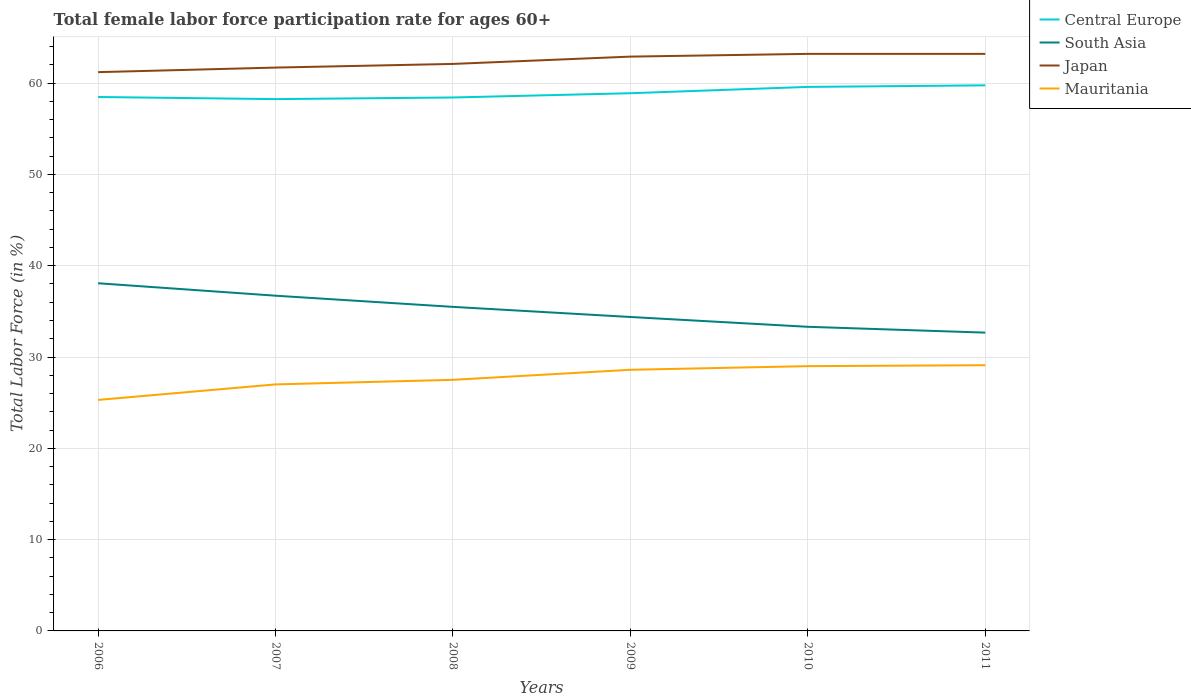How many different coloured lines are there?
Make the answer very short. 4. Is the number of lines equal to the number of legend labels?
Give a very brief answer. Yes. Across all years, what is the maximum female labor force participation rate in Mauritania?
Provide a succinct answer. 25.3. What is the total female labor force participation rate in South Asia in the graph?
Ensure brevity in your answer.  0.64. What is the difference between the highest and the second highest female labor force participation rate in Central Europe?
Provide a succinct answer. 1.51. What is the difference between the highest and the lowest female labor force participation rate in Central Europe?
Provide a short and direct response. 2. How many lines are there?
Keep it short and to the point. 4. How many years are there in the graph?
Make the answer very short. 6. What is the difference between two consecutive major ticks on the Y-axis?
Your answer should be compact. 10. Where does the legend appear in the graph?
Your response must be concise. Top right. What is the title of the graph?
Give a very brief answer. Total female labor force participation rate for ages 60+. Does "Indonesia" appear as one of the legend labels in the graph?
Ensure brevity in your answer.  No. What is the label or title of the Y-axis?
Keep it short and to the point. Total Labor Force (in %). What is the Total Labor Force (in %) of Central Europe in 2006?
Provide a succinct answer. 58.48. What is the Total Labor Force (in %) of South Asia in 2006?
Offer a terse response. 38.08. What is the Total Labor Force (in %) of Japan in 2006?
Make the answer very short. 61.2. What is the Total Labor Force (in %) of Mauritania in 2006?
Your answer should be very brief. 25.3. What is the Total Labor Force (in %) in Central Europe in 2007?
Your response must be concise. 58.25. What is the Total Labor Force (in %) of South Asia in 2007?
Make the answer very short. 36.72. What is the Total Labor Force (in %) in Japan in 2007?
Offer a very short reply. 61.7. What is the Total Labor Force (in %) in Central Europe in 2008?
Offer a terse response. 58.42. What is the Total Labor Force (in %) in South Asia in 2008?
Provide a succinct answer. 35.49. What is the Total Labor Force (in %) of Japan in 2008?
Your answer should be compact. 62.1. What is the Total Labor Force (in %) in Central Europe in 2009?
Offer a very short reply. 58.89. What is the Total Labor Force (in %) of South Asia in 2009?
Provide a short and direct response. 34.38. What is the Total Labor Force (in %) in Japan in 2009?
Provide a short and direct response. 62.9. What is the Total Labor Force (in %) in Mauritania in 2009?
Offer a terse response. 28.6. What is the Total Labor Force (in %) of Central Europe in 2010?
Your answer should be very brief. 59.58. What is the Total Labor Force (in %) in South Asia in 2010?
Your response must be concise. 33.31. What is the Total Labor Force (in %) of Japan in 2010?
Offer a terse response. 63.2. What is the Total Labor Force (in %) in Mauritania in 2010?
Keep it short and to the point. 29. What is the Total Labor Force (in %) in Central Europe in 2011?
Your response must be concise. 59.75. What is the Total Labor Force (in %) in South Asia in 2011?
Keep it short and to the point. 32.67. What is the Total Labor Force (in %) of Japan in 2011?
Ensure brevity in your answer.  63.2. What is the Total Labor Force (in %) in Mauritania in 2011?
Make the answer very short. 29.1. Across all years, what is the maximum Total Labor Force (in %) in Central Europe?
Provide a short and direct response. 59.75. Across all years, what is the maximum Total Labor Force (in %) in South Asia?
Provide a succinct answer. 38.08. Across all years, what is the maximum Total Labor Force (in %) of Japan?
Provide a succinct answer. 63.2. Across all years, what is the maximum Total Labor Force (in %) in Mauritania?
Keep it short and to the point. 29.1. Across all years, what is the minimum Total Labor Force (in %) in Central Europe?
Make the answer very short. 58.25. Across all years, what is the minimum Total Labor Force (in %) of South Asia?
Ensure brevity in your answer.  32.67. Across all years, what is the minimum Total Labor Force (in %) in Japan?
Offer a very short reply. 61.2. Across all years, what is the minimum Total Labor Force (in %) of Mauritania?
Offer a terse response. 25.3. What is the total Total Labor Force (in %) of Central Europe in the graph?
Keep it short and to the point. 353.37. What is the total Total Labor Force (in %) of South Asia in the graph?
Provide a succinct answer. 210.65. What is the total Total Labor Force (in %) in Japan in the graph?
Provide a short and direct response. 374.3. What is the total Total Labor Force (in %) in Mauritania in the graph?
Provide a short and direct response. 166.5. What is the difference between the Total Labor Force (in %) of Central Europe in 2006 and that in 2007?
Provide a succinct answer. 0.23. What is the difference between the Total Labor Force (in %) of South Asia in 2006 and that in 2007?
Offer a very short reply. 1.36. What is the difference between the Total Labor Force (in %) in Japan in 2006 and that in 2007?
Make the answer very short. -0.5. What is the difference between the Total Labor Force (in %) of Central Europe in 2006 and that in 2008?
Keep it short and to the point. 0.05. What is the difference between the Total Labor Force (in %) of South Asia in 2006 and that in 2008?
Offer a very short reply. 2.59. What is the difference between the Total Labor Force (in %) of Central Europe in 2006 and that in 2009?
Provide a short and direct response. -0.41. What is the difference between the Total Labor Force (in %) of South Asia in 2006 and that in 2009?
Keep it short and to the point. 3.69. What is the difference between the Total Labor Force (in %) of Japan in 2006 and that in 2009?
Your answer should be compact. -1.7. What is the difference between the Total Labor Force (in %) in Mauritania in 2006 and that in 2009?
Offer a terse response. -3.3. What is the difference between the Total Labor Force (in %) in Central Europe in 2006 and that in 2010?
Ensure brevity in your answer.  -1.11. What is the difference between the Total Labor Force (in %) of South Asia in 2006 and that in 2010?
Your response must be concise. 4.77. What is the difference between the Total Labor Force (in %) of Mauritania in 2006 and that in 2010?
Provide a succinct answer. -3.7. What is the difference between the Total Labor Force (in %) in Central Europe in 2006 and that in 2011?
Your answer should be compact. -1.28. What is the difference between the Total Labor Force (in %) in South Asia in 2006 and that in 2011?
Provide a short and direct response. 5.41. What is the difference between the Total Labor Force (in %) in Japan in 2006 and that in 2011?
Make the answer very short. -2. What is the difference between the Total Labor Force (in %) of Mauritania in 2006 and that in 2011?
Offer a terse response. -3.8. What is the difference between the Total Labor Force (in %) in Central Europe in 2007 and that in 2008?
Give a very brief answer. -0.18. What is the difference between the Total Labor Force (in %) in South Asia in 2007 and that in 2008?
Ensure brevity in your answer.  1.22. What is the difference between the Total Labor Force (in %) in Central Europe in 2007 and that in 2009?
Ensure brevity in your answer.  -0.64. What is the difference between the Total Labor Force (in %) in South Asia in 2007 and that in 2009?
Offer a terse response. 2.33. What is the difference between the Total Labor Force (in %) in Mauritania in 2007 and that in 2009?
Provide a short and direct response. -1.6. What is the difference between the Total Labor Force (in %) of Central Europe in 2007 and that in 2010?
Keep it short and to the point. -1.34. What is the difference between the Total Labor Force (in %) of South Asia in 2007 and that in 2010?
Your answer should be very brief. 3.41. What is the difference between the Total Labor Force (in %) of Japan in 2007 and that in 2010?
Give a very brief answer. -1.5. What is the difference between the Total Labor Force (in %) of Mauritania in 2007 and that in 2010?
Your response must be concise. -2. What is the difference between the Total Labor Force (in %) in Central Europe in 2007 and that in 2011?
Your response must be concise. -1.51. What is the difference between the Total Labor Force (in %) in South Asia in 2007 and that in 2011?
Your response must be concise. 4.04. What is the difference between the Total Labor Force (in %) of Central Europe in 2008 and that in 2009?
Your answer should be compact. -0.47. What is the difference between the Total Labor Force (in %) in South Asia in 2008 and that in 2009?
Provide a succinct answer. 1.11. What is the difference between the Total Labor Force (in %) in Japan in 2008 and that in 2009?
Ensure brevity in your answer.  -0.8. What is the difference between the Total Labor Force (in %) in Central Europe in 2008 and that in 2010?
Your answer should be very brief. -1.16. What is the difference between the Total Labor Force (in %) in South Asia in 2008 and that in 2010?
Your response must be concise. 2.18. What is the difference between the Total Labor Force (in %) in Central Europe in 2008 and that in 2011?
Your answer should be compact. -1.33. What is the difference between the Total Labor Force (in %) in South Asia in 2008 and that in 2011?
Your answer should be compact. 2.82. What is the difference between the Total Labor Force (in %) in Japan in 2008 and that in 2011?
Offer a terse response. -1.1. What is the difference between the Total Labor Force (in %) in Mauritania in 2008 and that in 2011?
Provide a short and direct response. -1.6. What is the difference between the Total Labor Force (in %) in Central Europe in 2009 and that in 2010?
Keep it short and to the point. -0.69. What is the difference between the Total Labor Force (in %) of South Asia in 2009 and that in 2010?
Offer a very short reply. 1.07. What is the difference between the Total Labor Force (in %) in Central Europe in 2009 and that in 2011?
Give a very brief answer. -0.86. What is the difference between the Total Labor Force (in %) of South Asia in 2009 and that in 2011?
Make the answer very short. 1.71. What is the difference between the Total Labor Force (in %) of Mauritania in 2009 and that in 2011?
Make the answer very short. -0.5. What is the difference between the Total Labor Force (in %) in Central Europe in 2010 and that in 2011?
Offer a terse response. -0.17. What is the difference between the Total Labor Force (in %) of South Asia in 2010 and that in 2011?
Provide a succinct answer. 0.64. What is the difference between the Total Labor Force (in %) in Japan in 2010 and that in 2011?
Give a very brief answer. 0. What is the difference between the Total Labor Force (in %) of Central Europe in 2006 and the Total Labor Force (in %) of South Asia in 2007?
Provide a succinct answer. 21.76. What is the difference between the Total Labor Force (in %) of Central Europe in 2006 and the Total Labor Force (in %) of Japan in 2007?
Offer a very short reply. -3.22. What is the difference between the Total Labor Force (in %) in Central Europe in 2006 and the Total Labor Force (in %) in Mauritania in 2007?
Keep it short and to the point. 31.48. What is the difference between the Total Labor Force (in %) of South Asia in 2006 and the Total Labor Force (in %) of Japan in 2007?
Ensure brevity in your answer.  -23.62. What is the difference between the Total Labor Force (in %) in South Asia in 2006 and the Total Labor Force (in %) in Mauritania in 2007?
Give a very brief answer. 11.08. What is the difference between the Total Labor Force (in %) in Japan in 2006 and the Total Labor Force (in %) in Mauritania in 2007?
Keep it short and to the point. 34.2. What is the difference between the Total Labor Force (in %) in Central Europe in 2006 and the Total Labor Force (in %) in South Asia in 2008?
Provide a short and direct response. 22.99. What is the difference between the Total Labor Force (in %) of Central Europe in 2006 and the Total Labor Force (in %) of Japan in 2008?
Offer a terse response. -3.62. What is the difference between the Total Labor Force (in %) in Central Europe in 2006 and the Total Labor Force (in %) in Mauritania in 2008?
Keep it short and to the point. 30.98. What is the difference between the Total Labor Force (in %) in South Asia in 2006 and the Total Labor Force (in %) in Japan in 2008?
Keep it short and to the point. -24.02. What is the difference between the Total Labor Force (in %) of South Asia in 2006 and the Total Labor Force (in %) of Mauritania in 2008?
Your response must be concise. 10.58. What is the difference between the Total Labor Force (in %) in Japan in 2006 and the Total Labor Force (in %) in Mauritania in 2008?
Your answer should be compact. 33.7. What is the difference between the Total Labor Force (in %) in Central Europe in 2006 and the Total Labor Force (in %) in South Asia in 2009?
Ensure brevity in your answer.  24.09. What is the difference between the Total Labor Force (in %) of Central Europe in 2006 and the Total Labor Force (in %) of Japan in 2009?
Offer a very short reply. -4.42. What is the difference between the Total Labor Force (in %) in Central Europe in 2006 and the Total Labor Force (in %) in Mauritania in 2009?
Provide a succinct answer. 29.88. What is the difference between the Total Labor Force (in %) in South Asia in 2006 and the Total Labor Force (in %) in Japan in 2009?
Your answer should be compact. -24.82. What is the difference between the Total Labor Force (in %) in South Asia in 2006 and the Total Labor Force (in %) in Mauritania in 2009?
Make the answer very short. 9.48. What is the difference between the Total Labor Force (in %) in Japan in 2006 and the Total Labor Force (in %) in Mauritania in 2009?
Make the answer very short. 32.6. What is the difference between the Total Labor Force (in %) of Central Europe in 2006 and the Total Labor Force (in %) of South Asia in 2010?
Offer a terse response. 25.17. What is the difference between the Total Labor Force (in %) in Central Europe in 2006 and the Total Labor Force (in %) in Japan in 2010?
Offer a terse response. -4.72. What is the difference between the Total Labor Force (in %) of Central Europe in 2006 and the Total Labor Force (in %) of Mauritania in 2010?
Ensure brevity in your answer.  29.48. What is the difference between the Total Labor Force (in %) of South Asia in 2006 and the Total Labor Force (in %) of Japan in 2010?
Make the answer very short. -25.12. What is the difference between the Total Labor Force (in %) of South Asia in 2006 and the Total Labor Force (in %) of Mauritania in 2010?
Provide a succinct answer. 9.08. What is the difference between the Total Labor Force (in %) in Japan in 2006 and the Total Labor Force (in %) in Mauritania in 2010?
Your answer should be compact. 32.2. What is the difference between the Total Labor Force (in %) in Central Europe in 2006 and the Total Labor Force (in %) in South Asia in 2011?
Offer a very short reply. 25.81. What is the difference between the Total Labor Force (in %) of Central Europe in 2006 and the Total Labor Force (in %) of Japan in 2011?
Your answer should be compact. -4.72. What is the difference between the Total Labor Force (in %) of Central Europe in 2006 and the Total Labor Force (in %) of Mauritania in 2011?
Keep it short and to the point. 29.38. What is the difference between the Total Labor Force (in %) in South Asia in 2006 and the Total Labor Force (in %) in Japan in 2011?
Your response must be concise. -25.12. What is the difference between the Total Labor Force (in %) in South Asia in 2006 and the Total Labor Force (in %) in Mauritania in 2011?
Make the answer very short. 8.98. What is the difference between the Total Labor Force (in %) of Japan in 2006 and the Total Labor Force (in %) of Mauritania in 2011?
Give a very brief answer. 32.1. What is the difference between the Total Labor Force (in %) of Central Europe in 2007 and the Total Labor Force (in %) of South Asia in 2008?
Make the answer very short. 22.75. What is the difference between the Total Labor Force (in %) of Central Europe in 2007 and the Total Labor Force (in %) of Japan in 2008?
Your answer should be very brief. -3.85. What is the difference between the Total Labor Force (in %) in Central Europe in 2007 and the Total Labor Force (in %) in Mauritania in 2008?
Make the answer very short. 30.75. What is the difference between the Total Labor Force (in %) in South Asia in 2007 and the Total Labor Force (in %) in Japan in 2008?
Provide a succinct answer. -25.38. What is the difference between the Total Labor Force (in %) of South Asia in 2007 and the Total Labor Force (in %) of Mauritania in 2008?
Your answer should be very brief. 9.22. What is the difference between the Total Labor Force (in %) of Japan in 2007 and the Total Labor Force (in %) of Mauritania in 2008?
Your answer should be compact. 34.2. What is the difference between the Total Labor Force (in %) of Central Europe in 2007 and the Total Labor Force (in %) of South Asia in 2009?
Your response must be concise. 23.86. What is the difference between the Total Labor Force (in %) in Central Europe in 2007 and the Total Labor Force (in %) in Japan in 2009?
Provide a succinct answer. -4.65. What is the difference between the Total Labor Force (in %) in Central Europe in 2007 and the Total Labor Force (in %) in Mauritania in 2009?
Your answer should be very brief. 29.65. What is the difference between the Total Labor Force (in %) in South Asia in 2007 and the Total Labor Force (in %) in Japan in 2009?
Ensure brevity in your answer.  -26.18. What is the difference between the Total Labor Force (in %) in South Asia in 2007 and the Total Labor Force (in %) in Mauritania in 2009?
Your answer should be compact. 8.12. What is the difference between the Total Labor Force (in %) in Japan in 2007 and the Total Labor Force (in %) in Mauritania in 2009?
Provide a short and direct response. 33.1. What is the difference between the Total Labor Force (in %) of Central Europe in 2007 and the Total Labor Force (in %) of South Asia in 2010?
Your answer should be very brief. 24.94. What is the difference between the Total Labor Force (in %) of Central Europe in 2007 and the Total Labor Force (in %) of Japan in 2010?
Give a very brief answer. -4.95. What is the difference between the Total Labor Force (in %) of Central Europe in 2007 and the Total Labor Force (in %) of Mauritania in 2010?
Provide a succinct answer. 29.25. What is the difference between the Total Labor Force (in %) of South Asia in 2007 and the Total Labor Force (in %) of Japan in 2010?
Your answer should be very brief. -26.48. What is the difference between the Total Labor Force (in %) of South Asia in 2007 and the Total Labor Force (in %) of Mauritania in 2010?
Provide a succinct answer. 7.72. What is the difference between the Total Labor Force (in %) in Japan in 2007 and the Total Labor Force (in %) in Mauritania in 2010?
Your answer should be compact. 32.7. What is the difference between the Total Labor Force (in %) of Central Europe in 2007 and the Total Labor Force (in %) of South Asia in 2011?
Your answer should be very brief. 25.58. What is the difference between the Total Labor Force (in %) of Central Europe in 2007 and the Total Labor Force (in %) of Japan in 2011?
Your response must be concise. -4.95. What is the difference between the Total Labor Force (in %) in Central Europe in 2007 and the Total Labor Force (in %) in Mauritania in 2011?
Your answer should be very brief. 29.15. What is the difference between the Total Labor Force (in %) of South Asia in 2007 and the Total Labor Force (in %) of Japan in 2011?
Give a very brief answer. -26.48. What is the difference between the Total Labor Force (in %) in South Asia in 2007 and the Total Labor Force (in %) in Mauritania in 2011?
Your response must be concise. 7.62. What is the difference between the Total Labor Force (in %) in Japan in 2007 and the Total Labor Force (in %) in Mauritania in 2011?
Your answer should be very brief. 32.6. What is the difference between the Total Labor Force (in %) in Central Europe in 2008 and the Total Labor Force (in %) in South Asia in 2009?
Offer a very short reply. 24.04. What is the difference between the Total Labor Force (in %) of Central Europe in 2008 and the Total Labor Force (in %) of Japan in 2009?
Your answer should be very brief. -4.48. What is the difference between the Total Labor Force (in %) in Central Europe in 2008 and the Total Labor Force (in %) in Mauritania in 2009?
Make the answer very short. 29.82. What is the difference between the Total Labor Force (in %) in South Asia in 2008 and the Total Labor Force (in %) in Japan in 2009?
Offer a terse response. -27.41. What is the difference between the Total Labor Force (in %) in South Asia in 2008 and the Total Labor Force (in %) in Mauritania in 2009?
Your response must be concise. 6.89. What is the difference between the Total Labor Force (in %) of Japan in 2008 and the Total Labor Force (in %) of Mauritania in 2009?
Your answer should be very brief. 33.5. What is the difference between the Total Labor Force (in %) of Central Europe in 2008 and the Total Labor Force (in %) of South Asia in 2010?
Ensure brevity in your answer.  25.11. What is the difference between the Total Labor Force (in %) of Central Europe in 2008 and the Total Labor Force (in %) of Japan in 2010?
Provide a short and direct response. -4.78. What is the difference between the Total Labor Force (in %) in Central Europe in 2008 and the Total Labor Force (in %) in Mauritania in 2010?
Provide a succinct answer. 29.42. What is the difference between the Total Labor Force (in %) in South Asia in 2008 and the Total Labor Force (in %) in Japan in 2010?
Keep it short and to the point. -27.71. What is the difference between the Total Labor Force (in %) of South Asia in 2008 and the Total Labor Force (in %) of Mauritania in 2010?
Ensure brevity in your answer.  6.49. What is the difference between the Total Labor Force (in %) of Japan in 2008 and the Total Labor Force (in %) of Mauritania in 2010?
Offer a terse response. 33.1. What is the difference between the Total Labor Force (in %) of Central Europe in 2008 and the Total Labor Force (in %) of South Asia in 2011?
Keep it short and to the point. 25.75. What is the difference between the Total Labor Force (in %) of Central Europe in 2008 and the Total Labor Force (in %) of Japan in 2011?
Provide a succinct answer. -4.78. What is the difference between the Total Labor Force (in %) of Central Europe in 2008 and the Total Labor Force (in %) of Mauritania in 2011?
Ensure brevity in your answer.  29.32. What is the difference between the Total Labor Force (in %) in South Asia in 2008 and the Total Labor Force (in %) in Japan in 2011?
Your response must be concise. -27.71. What is the difference between the Total Labor Force (in %) in South Asia in 2008 and the Total Labor Force (in %) in Mauritania in 2011?
Give a very brief answer. 6.39. What is the difference between the Total Labor Force (in %) in Central Europe in 2009 and the Total Labor Force (in %) in South Asia in 2010?
Your answer should be compact. 25.58. What is the difference between the Total Labor Force (in %) in Central Europe in 2009 and the Total Labor Force (in %) in Japan in 2010?
Provide a succinct answer. -4.31. What is the difference between the Total Labor Force (in %) in Central Europe in 2009 and the Total Labor Force (in %) in Mauritania in 2010?
Give a very brief answer. 29.89. What is the difference between the Total Labor Force (in %) of South Asia in 2009 and the Total Labor Force (in %) of Japan in 2010?
Keep it short and to the point. -28.82. What is the difference between the Total Labor Force (in %) in South Asia in 2009 and the Total Labor Force (in %) in Mauritania in 2010?
Your answer should be compact. 5.38. What is the difference between the Total Labor Force (in %) of Japan in 2009 and the Total Labor Force (in %) of Mauritania in 2010?
Ensure brevity in your answer.  33.9. What is the difference between the Total Labor Force (in %) of Central Europe in 2009 and the Total Labor Force (in %) of South Asia in 2011?
Your answer should be compact. 26.22. What is the difference between the Total Labor Force (in %) of Central Europe in 2009 and the Total Labor Force (in %) of Japan in 2011?
Provide a short and direct response. -4.31. What is the difference between the Total Labor Force (in %) of Central Europe in 2009 and the Total Labor Force (in %) of Mauritania in 2011?
Your response must be concise. 29.79. What is the difference between the Total Labor Force (in %) of South Asia in 2009 and the Total Labor Force (in %) of Japan in 2011?
Provide a succinct answer. -28.82. What is the difference between the Total Labor Force (in %) of South Asia in 2009 and the Total Labor Force (in %) of Mauritania in 2011?
Offer a very short reply. 5.28. What is the difference between the Total Labor Force (in %) of Japan in 2009 and the Total Labor Force (in %) of Mauritania in 2011?
Provide a succinct answer. 33.8. What is the difference between the Total Labor Force (in %) of Central Europe in 2010 and the Total Labor Force (in %) of South Asia in 2011?
Give a very brief answer. 26.91. What is the difference between the Total Labor Force (in %) in Central Europe in 2010 and the Total Labor Force (in %) in Japan in 2011?
Make the answer very short. -3.62. What is the difference between the Total Labor Force (in %) in Central Europe in 2010 and the Total Labor Force (in %) in Mauritania in 2011?
Offer a terse response. 30.48. What is the difference between the Total Labor Force (in %) of South Asia in 2010 and the Total Labor Force (in %) of Japan in 2011?
Give a very brief answer. -29.89. What is the difference between the Total Labor Force (in %) in South Asia in 2010 and the Total Labor Force (in %) in Mauritania in 2011?
Your answer should be compact. 4.21. What is the difference between the Total Labor Force (in %) in Japan in 2010 and the Total Labor Force (in %) in Mauritania in 2011?
Make the answer very short. 34.1. What is the average Total Labor Force (in %) in Central Europe per year?
Offer a very short reply. 58.9. What is the average Total Labor Force (in %) of South Asia per year?
Offer a terse response. 35.11. What is the average Total Labor Force (in %) of Japan per year?
Offer a terse response. 62.38. What is the average Total Labor Force (in %) in Mauritania per year?
Your response must be concise. 27.75. In the year 2006, what is the difference between the Total Labor Force (in %) in Central Europe and Total Labor Force (in %) in South Asia?
Keep it short and to the point. 20.4. In the year 2006, what is the difference between the Total Labor Force (in %) in Central Europe and Total Labor Force (in %) in Japan?
Ensure brevity in your answer.  -2.72. In the year 2006, what is the difference between the Total Labor Force (in %) in Central Europe and Total Labor Force (in %) in Mauritania?
Give a very brief answer. 33.18. In the year 2006, what is the difference between the Total Labor Force (in %) of South Asia and Total Labor Force (in %) of Japan?
Provide a succinct answer. -23.12. In the year 2006, what is the difference between the Total Labor Force (in %) of South Asia and Total Labor Force (in %) of Mauritania?
Make the answer very short. 12.78. In the year 2006, what is the difference between the Total Labor Force (in %) of Japan and Total Labor Force (in %) of Mauritania?
Your answer should be compact. 35.9. In the year 2007, what is the difference between the Total Labor Force (in %) in Central Europe and Total Labor Force (in %) in South Asia?
Provide a short and direct response. 21.53. In the year 2007, what is the difference between the Total Labor Force (in %) in Central Europe and Total Labor Force (in %) in Japan?
Provide a succinct answer. -3.45. In the year 2007, what is the difference between the Total Labor Force (in %) in Central Europe and Total Labor Force (in %) in Mauritania?
Give a very brief answer. 31.25. In the year 2007, what is the difference between the Total Labor Force (in %) in South Asia and Total Labor Force (in %) in Japan?
Make the answer very short. -24.98. In the year 2007, what is the difference between the Total Labor Force (in %) in South Asia and Total Labor Force (in %) in Mauritania?
Provide a succinct answer. 9.72. In the year 2007, what is the difference between the Total Labor Force (in %) of Japan and Total Labor Force (in %) of Mauritania?
Offer a terse response. 34.7. In the year 2008, what is the difference between the Total Labor Force (in %) in Central Europe and Total Labor Force (in %) in South Asia?
Your answer should be very brief. 22.93. In the year 2008, what is the difference between the Total Labor Force (in %) of Central Europe and Total Labor Force (in %) of Japan?
Provide a short and direct response. -3.68. In the year 2008, what is the difference between the Total Labor Force (in %) in Central Europe and Total Labor Force (in %) in Mauritania?
Give a very brief answer. 30.92. In the year 2008, what is the difference between the Total Labor Force (in %) in South Asia and Total Labor Force (in %) in Japan?
Provide a short and direct response. -26.61. In the year 2008, what is the difference between the Total Labor Force (in %) in South Asia and Total Labor Force (in %) in Mauritania?
Provide a succinct answer. 7.99. In the year 2008, what is the difference between the Total Labor Force (in %) of Japan and Total Labor Force (in %) of Mauritania?
Provide a short and direct response. 34.6. In the year 2009, what is the difference between the Total Labor Force (in %) of Central Europe and Total Labor Force (in %) of South Asia?
Provide a short and direct response. 24.51. In the year 2009, what is the difference between the Total Labor Force (in %) of Central Europe and Total Labor Force (in %) of Japan?
Your answer should be very brief. -4.01. In the year 2009, what is the difference between the Total Labor Force (in %) of Central Europe and Total Labor Force (in %) of Mauritania?
Offer a very short reply. 30.29. In the year 2009, what is the difference between the Total Labor Force (in %) of South Asia and Total Labor Force (in %) of Japan?
Offer a very short reply. -28.52. In the year 2009, what is the difference between the Total Labor Force (in %) of South Asia and Total Labor Force (in %) of Mauritania?
Your answer should be compact. 5.78. In the year 2009, what is the difference between the Total Labor Force (in %) of Japan and Total Labor Force (in %) of Mauritania?
Make the answer very short. 34.3. In the year 2010, what is the difference between the Total Labor Force (in %) of Central Europe and Total Labor Force (in %) of South Asia?
Offer a terse response. 26.27. In the year 2010, what is the difference between the Total Labor Force (in %) in Central Europe and Total Labor Force (in %) in Japan?
Your response must be concise. -3.62. In the year 2010, what is the difference between the Total Labor Force (in %) in Central Europe and Total Labor Force (in %) in Mauritania?
Make the answer very short. 30.58. In the year 2010, what is the difference between the Total Labor Force (in %) of South Asia and Total Labor Force (in %) of Japan?
Offer a terse response. -29.89. In the year 2010, what is the difference between the Total Labor Force (in %) of South Asia and Total Labor Force (in %) of Mauritania?
Give a very brief answer. 4.31. In the year 2010, what is the difference between the Total Labor Force (in %) in Japan and Total Labor Force (in %) in Mauritania?
Offer a terse response. 34.2. In the year 2011, what is the difference between the Total Labor Force (in %) in Central Europe and Total Labor Force (in %) in South Asia?
Offer a terse response. 27.08. In the year 2011, what is the difference between the Total Labor Force (in %) in Central Europe and Total Labor Force (in %) in Japan?
Provide a succinct answer. -3.45. In the year 2011, what is the difference between the Total Labor Force (in %) in Central Europe and Total Labor Force (in %) in Mauritania?
Give a very brief answer. 30.65. In the year 2011, what is the difference between the Total Labor Force (in %) of South Asia and Total Labor Force (in %) of Japan?
Offer a very short reply. -30.53. In the year 2011, what is the difference between the Total Labor Force (in %) of South Asia and Total Labor Force (in %) of Mauritania?
Your answer should be compact. 3.57. In the year 2011, what is the difference between the Total Labor Force (in %) in Japan and Total Labor Force (in %) in Mauritania?
Give a very brief answer. 34.1. What is the ratio of the Total Labor Force (in %) of Central Europe in 2006 to that in 2007?
Make the answer very short. 1. What is the ratio of the Total Labor Force (in %) of South Asia in 2006 to that in 2007?
Provide a succinct answer. 1.04. What is the ratio of the Total Labor Force (in %) in Japan in 2006 to that in 2007?
Ensure brevity in your answer.  0.99. What is the ratio of the Total Labor Force (in %) of Mauritania in 2006 to that in 2007?
Provide a short and direct response. 0.94. What is the ratio of the Total Labor Force (in %) in Central Europe in 2006 to that in 2008?
Provide a succinct answer. 1. What is the ratio of the Total Labor Force (in %) in South Asia in 2006 to that in 2008?
Keep it short and to the point. 1.07. What is the ratio of the Total Labor Force (in %) of Japan in 2006 to that in 2008?
Ensure brevity in your answer.  0.99. What is the ratio of the Total Labor Force (in %) in South Asia in 2006 to that in 2009?
Offer a terse response. 1.11. What is the ratio of the Total Labor Force (in %) of Japan in 2006 to that in 2009?
Provide a short and direct response. 0.97. What is the ratio of the Total Labor Force (in %) of Mauritania in 2006 to that in 2009?
Offer a very short reply. 0.88. What is the ratio of the Total Labor Force (in %) of Central Europe in 2006 to that in 2010?
Provide a succinct answer. 0.98. What is the ratio of the Total Labor Force (in %) of South Asia in 2006 to that in 2010?
Your response must be concise. 1.14. What is the ratio of the Total Labor Force (in %) of Japan in 2006 to that in 2010?
Provide a short and direct response. 0.97. What is the ratio of the Total Labor Force (in %) of Mauritania in 2006 to that in 2010?
Your response must be concise. 0.87. What is the ratio of the Total Labor Force (in %) in Central Europe in 2006 to that in 2011?
Provide a succinct answer. 0.98. What is the ratio of the Total Labor Force (in %) in South Asia in 2006 to that in 2011?
Give a very brief answer. 1.17. What is the ratio of the Total Labor Force (in %) of Japan in 2006 to that in 2011?
Give a very brief answer. 0.97. What is the ratio of the Total Labor Force (in %) of Mauritania in 2006 to that in 2011?
Offer a very short reply. 0.87. What is the ratio of the Total Labor Force (in %) in Central Europe in 2007 to that in 2008?
Provide a short and direct response. 1. What is the ratio of the Total Labor Force (in %) of South Asia in 2007 to that in 2008?
Your answer should be very brief. 1.03. What is the ratio of the Total Labor Force (in %) in Mauritania in 2007 to that in 2008?
Your response must be concise. 0.98. What is the ratio of the Total Labor Force (in %) of Central Europe in 2007 to that in 2009?
Offer a very short reply. 0.99. What is the ratio of the Total Labor Force (in %) in South Asia in 2007 to that in 2009?
Provide a short and direct response. 1.07. What is the ratio of the Total Labor Force (in %) in Japan in 2007 to that in 2009?
Offer a terse response. 0.98. What is the ratio of the Total Labor Force (in %) of Mauritania in 2007 to that in 2009?
Ensure brevity in your answer.  0.94. What is the ratio of the Total Labor Force (in %) in Central Europe in 2007 to that in 2010?
Ensure brevity in your answer.  0.98. What is the ratio of the Total Labor Force (in %) of South Asia in 2007 to that in 2010?
Provide a succinct answer. 1.1. What is the ratio of the Total Labor Force (in %) in Japan in 2007 to that in 2010?
Make the answer very short. 0.98. What is the ratio of the Total Labor Force (in %) in Mauritania in 2007 to that in 2010?
Give a very brief answer. 0.93. What is the ratio of the Total Labor Force (in %) in Central Europe in 2007 to that in 2011?
Your response must be concise. 0.97. What is the ratio of the Total Labor Force (in %) of South Asia in 2007 to that in 2011?
Offer a very short reply. 1.12. What is the ratio of the Total Labor Force (in %) in Japan in 2007 to that in 2011?
Your response must be concise. 0.98. What is the ratio of the Total Labor Force (in %) in Mauritania in 2007 to that in 2011?
Ensure brevity in your answer.  0.93. What is the ratio of the Total Labor Force (in %) of Central Europe in 2008 to that in 2009?
Offer a terse response. 0.99. What is the ratio of the Total Labor Force (in %) in South Asia in 2008 to that in 2009?
Make the answer very short. 1.03. What is the ratio of the Total Labor Force (in %) in Japan in 2008 to that in 2009?
Offer a very short reply. 0.99. What is the ratio of the Total Labor Force (in %) of Mauritania in 2008 to that in 2009?
Provide a succinct answer. 0.96. What is the ratio of the Total Labor Force (in %) of Central Europe in 2008 to that in 2010?
Give a very brief answer. 0.98. What is the ratio of the Total Labor Force (in %) of South Asia in 2008 to that in 2010?
Your response must be concise. 1.07. What is the ratio of the Total Labor Force (in %) of Japan in 2008 to that in 2010?
Ensure brevity in your answer.  0.98. What is the ratio of the Total Labor Force (in %) of Mauritania in 2008 to that in 2010?
Your answer should be compact. 0.95. What is the ratio of the Total Labor Force (in %) of Central Europe in 2008 to that in 2011?
Keep it short and to the point. 0.98. What is the ratio of the Total Labor Force (in %) of South Asia in 2008 to that in 2011?
Make the answer very short. 1.09. What is the ratio of the Total Labor Force (in %) of Japan in 2008 to that in 2011?
Your answer should be very brief. 0.98. What is the ratio of the Total Labor Force (in %) of Mauritania in 2008 to that in 2011?
Ensure brevity in your answer.  0.94. What is the ratio of the Total Labor Force (in %) in Central Europe in 2009 to that in 2010?
Keep it short and to the point. 0.99. What is the ratio of the Total Labor Force (in %) in South Asia in 2009 to that in 2010?
Make the answer very short. 1.03. What is the ratio of the Total Labor Force (in %) of Mauritania in 2009 to that in 2010?
Keep it short and to the point. 0.99. What is the ratio of the Total Labor Force (in %) in Central Europe in 2009 to that in 2011?
Offer a very short reply. 0.99. What is the ratio of the Total Labor Force (in %) of South Asia in 2009 to that in 2011?
Keep it short and to the point. 1.05. What is the ratio of the Total Labor Force (in %) of Japan in 2009 to that in 2011?
Your answer should be compact. 1. What is the ratio of the Total Labor Force (in %) in Mauritania in 2009 to that in 2011?
Your response must be concise. 0.98. What is the ratio of the Total Labor Force (in %) of South Asia in 2010 to that in 2011?
Ensure brevity in your answer.  1.02. What is the ratio of the Total Labor Force (in %) in Japan in 2010 to that in 2011?
Ensure brevity in your answer.  1. What is the difference between the highest and the second highest Total Labor Force (in %) in Central Europe?
Your answer should be very brief. 0.17. What is the difference between the highest and the second highest Total Labor Force (in %) in South Asia?
Give a very brief answer. 1.36. What is the difference between the highest and the second highest Total Labor Force (in %) of Japan?
Your answer should be very brief. 0. What is the difference between the highest and the second highest Total Labor Force (in %) in Mauritania?
Give a very brief answer. 0.1. What is the difference between the highest and the lowest Total Labor Force (in %) in Central Europe?
Your answer should be very brief. 1.51. What is the difference between the highest and the lowest Total Labor Force (in %) of South Asia?
Give a very brief answer. 5.41. What is the difference between the highest and the lowest Total Labor Force (in %) of Japan?
Provide a succinct answer. 2. What is the difference between the highest and the lowest Total Labor Force (in %) of Mauritania?
Offer a terse response. 3.8. 